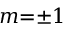Convert formula to latex. <formula><loc_0><loc_0><loc_500><loc_500>m { = } { \pm } 1</formula> 